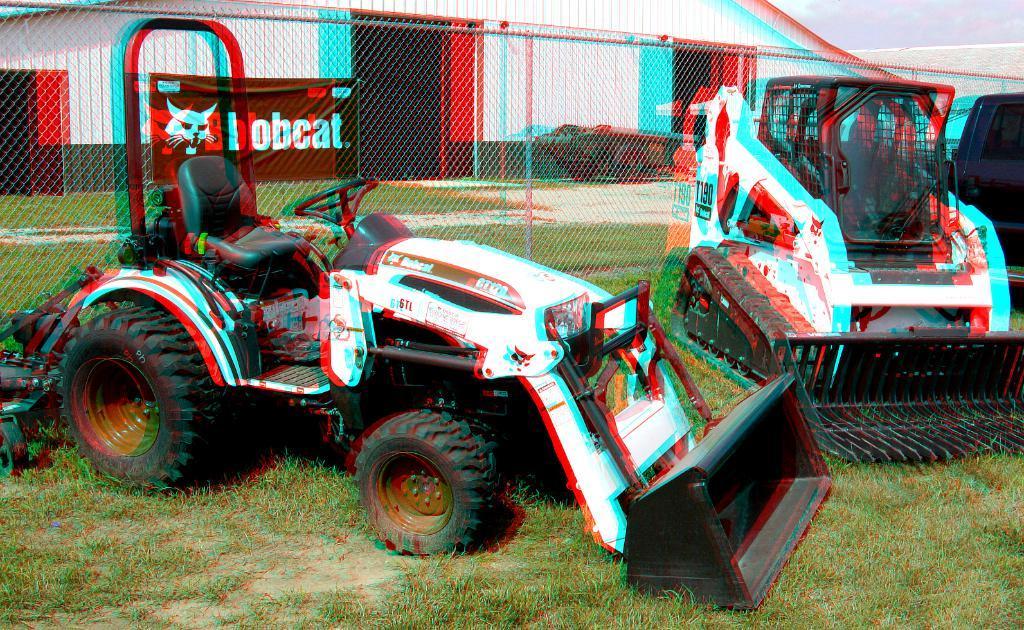Describe this image in one or two sentences. In this image we can see a vehicle on the grassy land. Behind the vehicles we can see the fencing and a shed. On the fencing we can see a banner with text. In the top right, we can see the sky. 